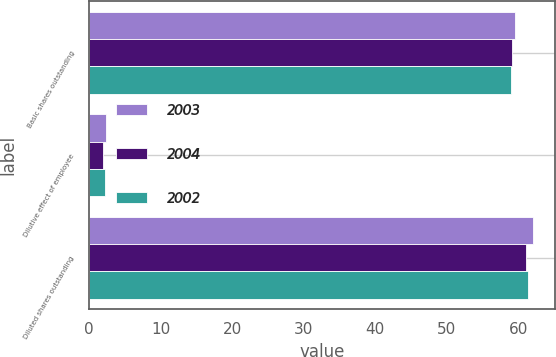Convert chart to OTSL. <chart><loc_0><loc_0><loc_500><loc_500><stacked_bar_chart><ecel><fcel>Basic shares outstanding<fcel>Dilutive effect of employee<fcel>Diluted shares outstanding<nl><fcel>2003<fcel>59.6<fcel>2.4<fcel>62<nl><fcel>2004<fcel>59.1<fcel>2<fcel>61.1<nl><fcel>2002<fcel>59<fcel>2.3<fcel>61.3<nl></chart> 